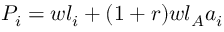Convert formula to latex. <formula><loc_0><loc_0><loc_500><loc_500>P _ { i } = w l _ { i } + ( 1 + r ) w l _ { A } a _ { i }</formula> 